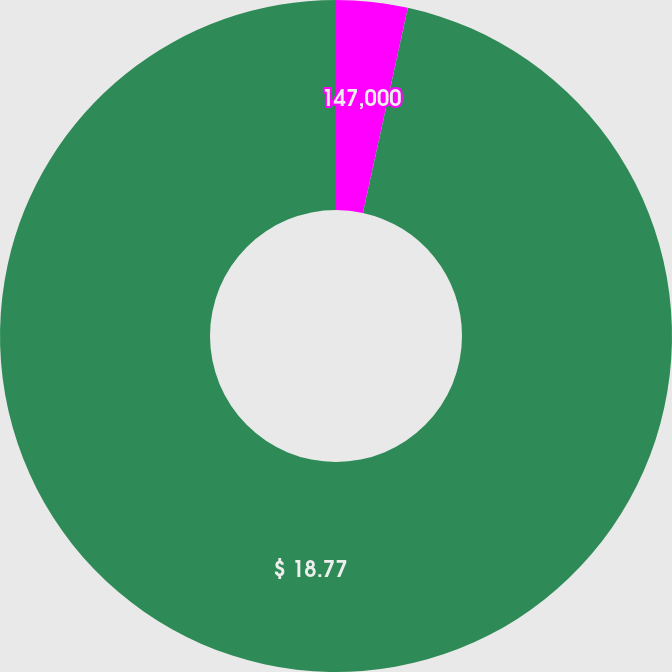Convert chart. <chart><loc_0><loc_0><loc_500><loc_500><pie_chart><fcel>$ 2,758,000<fcel>147,000<fcel>3.1%<fcel>$ 18.77<nl><fcel>0.0%<fcel>3.43%<fcel>0.0%<fcel>96.57%<nl></chart> 